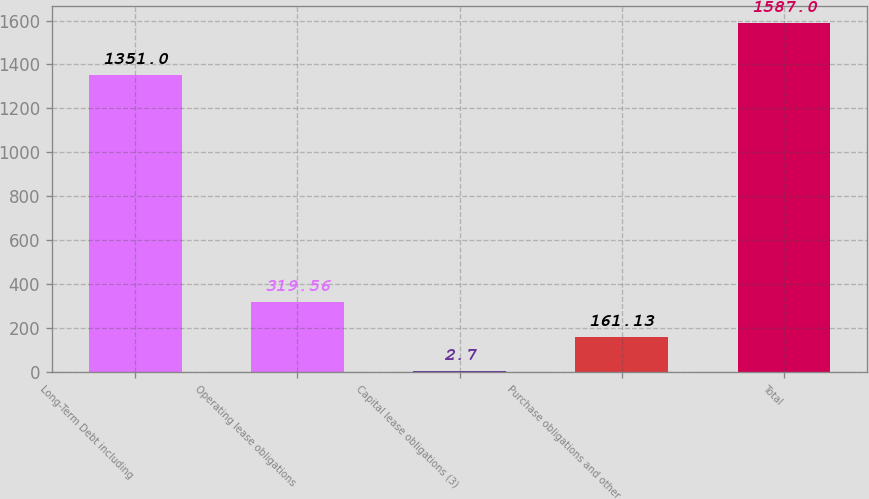Convert chart. <chart><loc_0><loc_0><loc_500><loc_500><bar_chart><fcel>Long-Term Debt including<fcel>Operating lease obligations<fcel>Capital lease obligations (3)<fcel>Purchase obligations and other<fcel>Total<nl><fcel>1351<fcel>319.56<fcel>2.7<fcel>161.13<fcel>1587<nl></chart> 